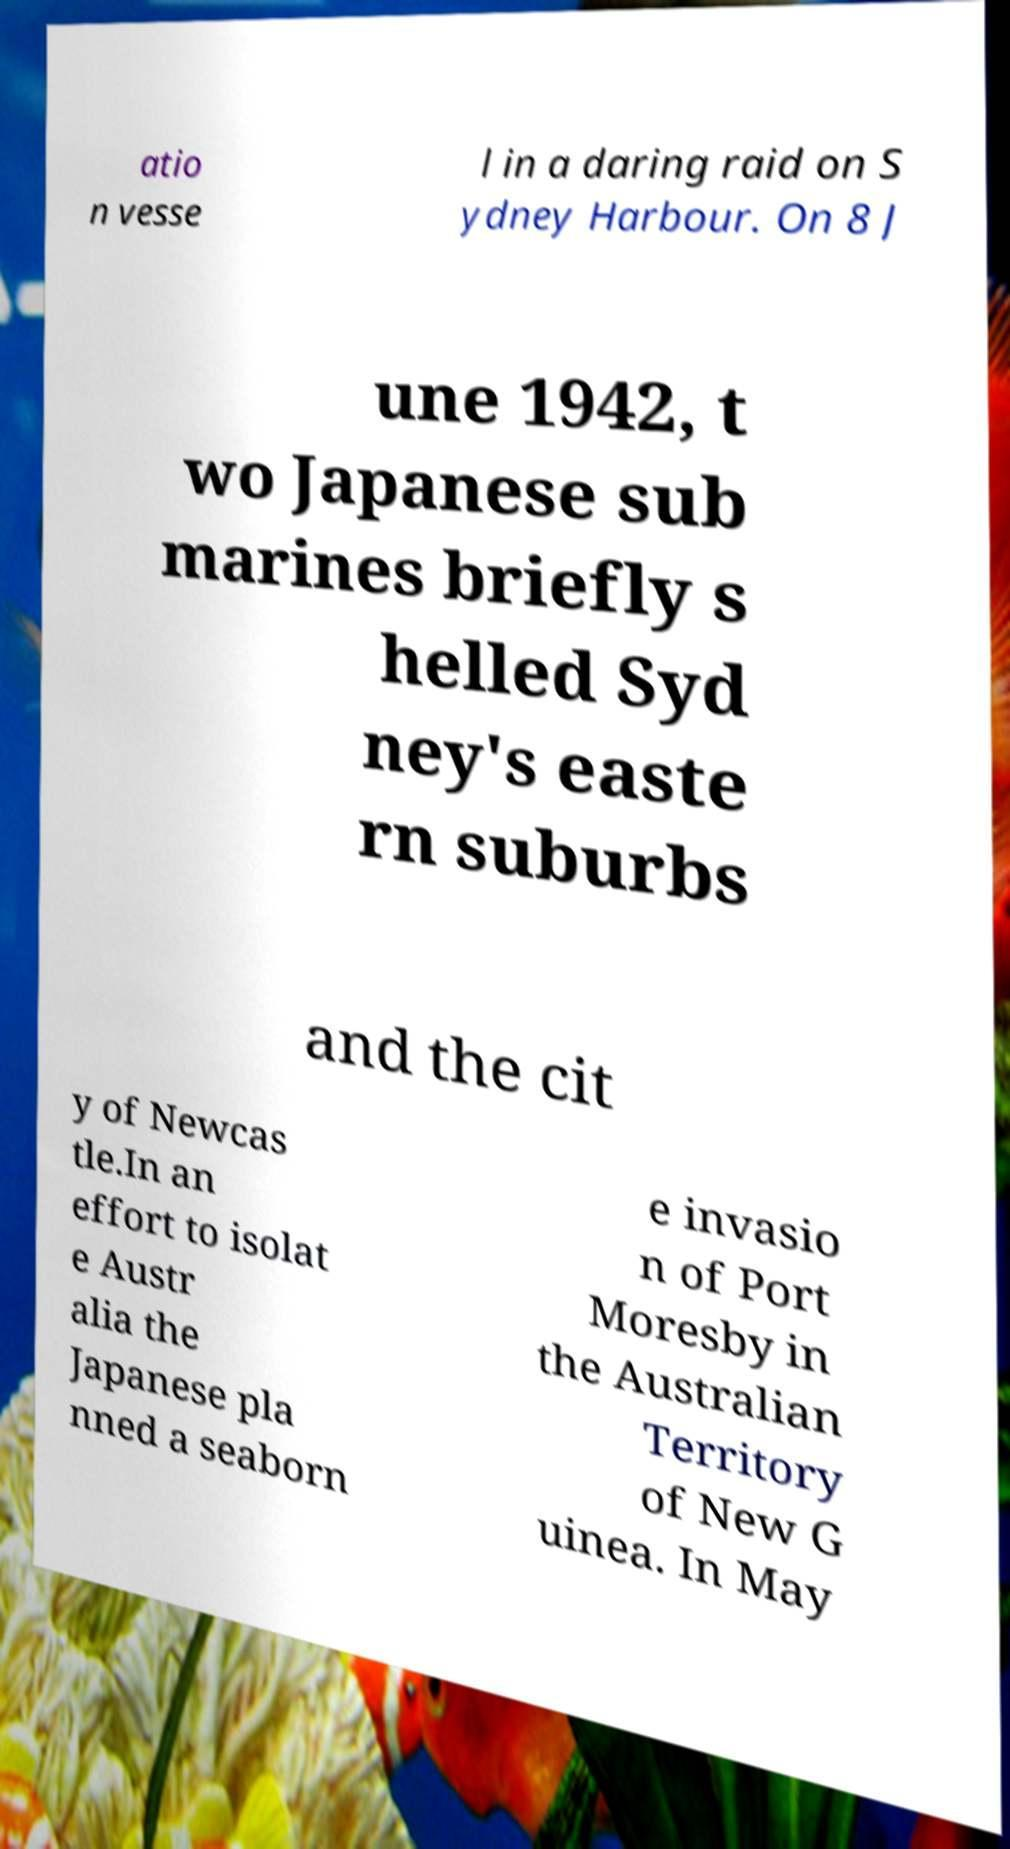Can you read and provide the text displayed in the image?This photo seems to have some interesting text. Can you extract and type it out for me? atio n vesse l in a daring raid on S ydney Harbour. On 8 J une 1942, t wo Japanese sub marines briefly s helled Syd ney's easte rn suburbs and the cit y of Newcas tle.In an effort to isolat e Austr alia the Japanese pla nned a seaborn e invasio n of Port Moresby in the Australian Territory of New G uinea. In May 